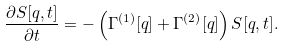<formula> <loc_0><loc_0><loc_500><loc_500>\frac { \partial S [ { q } , t ] } { \partial t } = - \left ( \Gamma ^ { ( 1 ) } [ { q } ] + \Gamma ^ { ( 2 ) } [ { q } ] \right ) S [ { q } , t ] .</formula> 